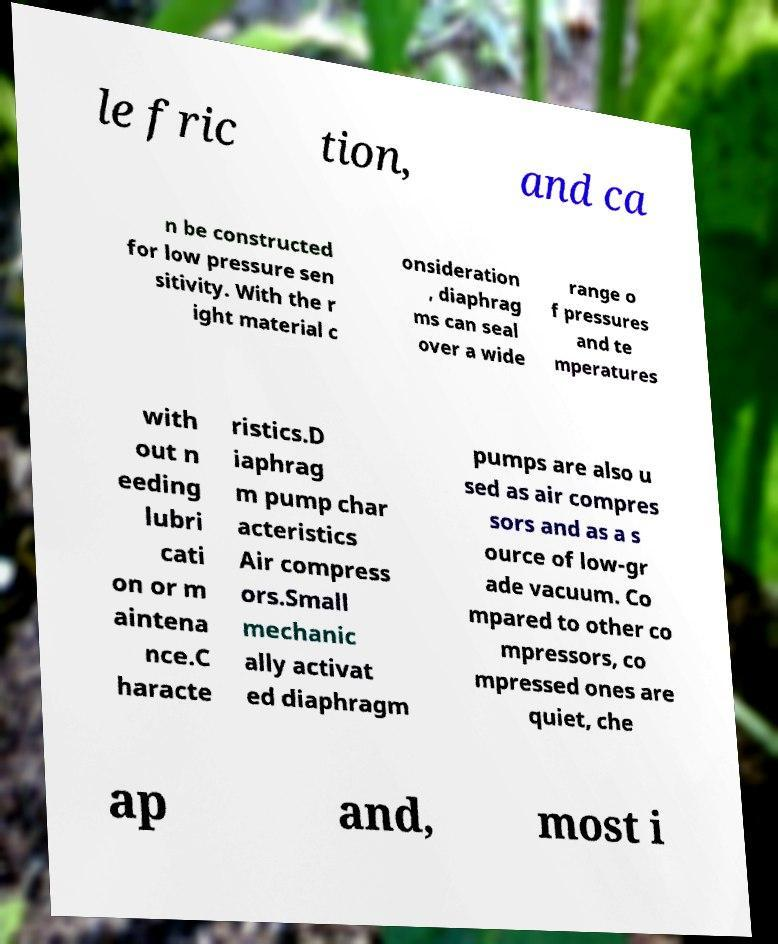I need the written content from this picture converted into text. Can you do that? le fric tion, and ca n be constructed for low pressure sen sitivity. With the r ight material c onsideration , diaphrag ms can seal over a wide range o f pressures and te mperatures with out n eeding lubri cati on or m aintena nce.C haracte ristics.D iaphrag m pump char acteristics Air compress ors.Small mechanic ally activat ed diaphragm pumps are also u sed as air compres sors and as a s ource of low-gr ade vacuum. Co mpared to other co mpressors, co mpressed ones are quiet, che ap and, most i 